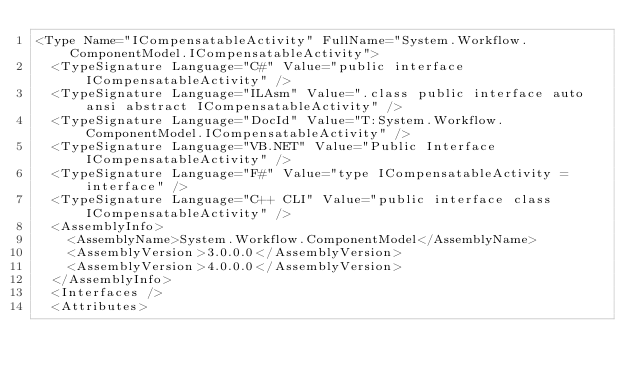Convert code to text. <code><loc_0><loc_0><loc_500><loc_500><_XML_><Type Name="ICompensatableActivity" FullName="System.Workflow.ComponentModel.ICompensatableActivity">
  <TypeSignature Language="C#" Value="public interface ICompensatableActivity" />
  <TypeSignature Language="ILAsm" Value=".class public interface auto ansi abstract ICompensatableActivity" />
  <TypeSignature Language="DocId" Value="T:System.Workflow.ComponentModel.ICompensatableActivity" />
  <TypeSignature Language="VB.NET" Value="Public Interface ICompensatableActivity" />
  <TypeSignature Language="F#" Value="type ICompensatableActivity = interface" />
  <TypeSignature Language="C++ CLI" Value="public interface class ICompensatableActivity" />
  <AssemblyInfo>
    <AssemblyName>System.Workflow.ComponentModel</AssemblyName>
    <AssemblyVersion>3.0.0.0</AssemblyVersion>
    <AssemblyVersion>4.0.0.0</AssemblyVersion>
  </AssemblyInfo>
  <Interfaces />
  <Attributes></code> 